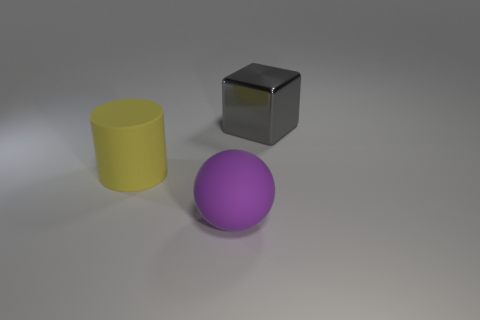Is there anything else that is the same material as the gray block?
Provide a short and direct response. No. Are there the same number of gray metal cubes to the right of the gray cube and big rubber spheres that are left of the large purple rubber object?
Provide a succinct answer. Yes. There is a thing that is on the right side of the matte thing on the right side of the matte cylinder; what is its shape?
Make the answer very short. Cube. What is the color of the sphere that is the same size as the yellow rubber object?
Keep it short and to the point. Purple. Are there an equal number of large gray things that are right of the big gray metal block and brown objects?
Provide a short and direct response. Yes. There is a thing to the left of the big matte thing to the right of the large matte cylinder; what color is it?
Offer a very short reply. Yellow. What size is the rubber thing that is behind the big matte object to the right of the yellow rubber object?
Your answer should be compact. Large. How many other objects are there of the same size as the purple ball?
Your response must be concise. 2. What color is the rubber object that is in front of the large object that is on the left side of the matte thing in front of the yellow thing?
Offer a terse response. Purple. What number of other objects are the same shape as the yellow rubber object?
Make the answer very short. 0. 